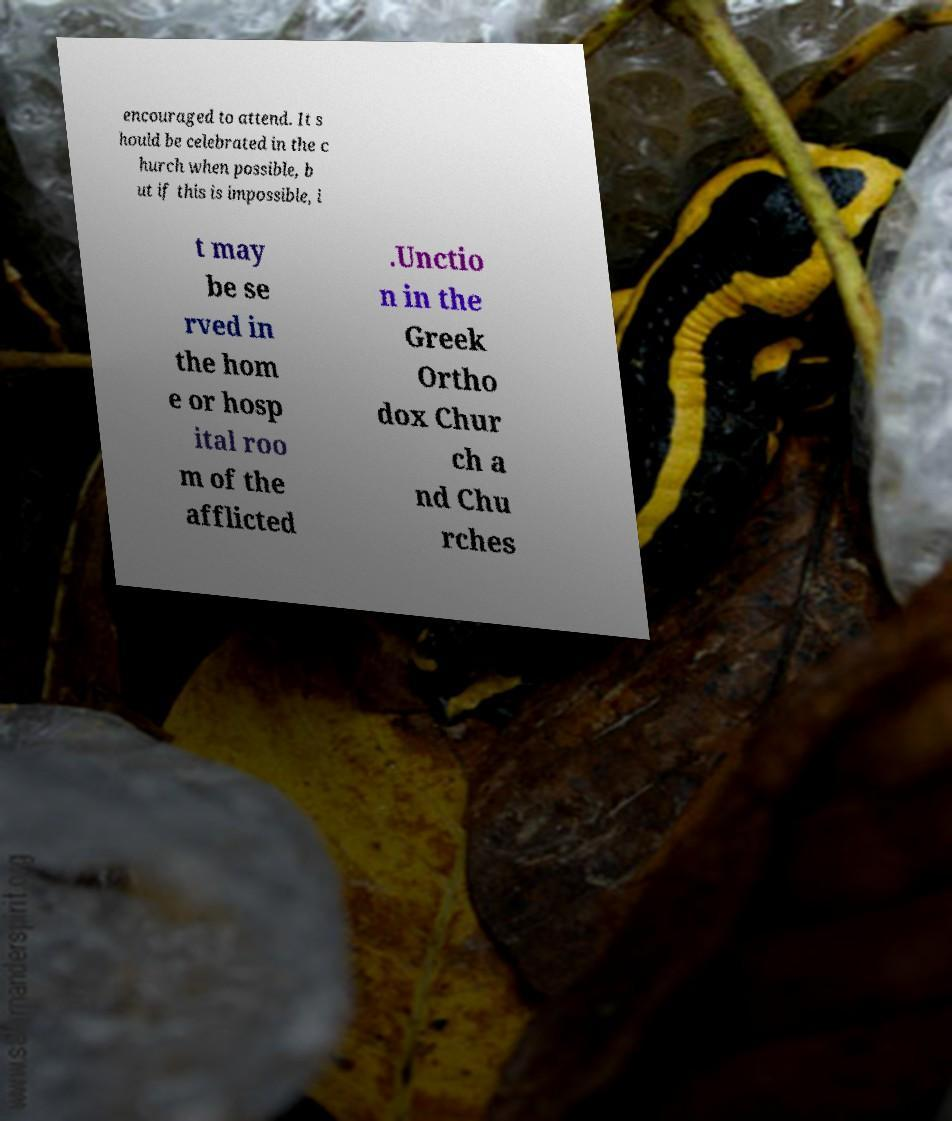Can you read and provide the text displayed in the image?This photo seems to have some interesting text. Can you extract and type it out for me? encouraged to attend. It s hould be celebrated in the c hurch when possible, b ut if this is impossible, i t may be se rved in the hom e or hosp ital roo m of the afflicted .Unctio n in the Greek Ortho dox Chur ch a nd Chu rches 